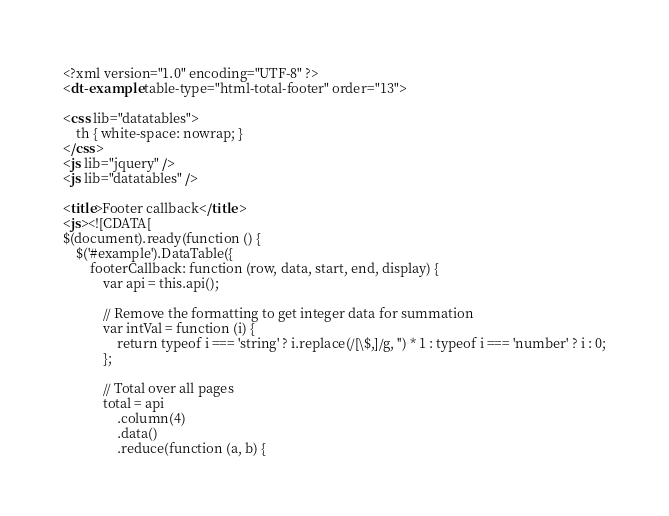Convert code to text. <code><loc_0><loc_0><loc_500><loc_500><_XML_><?xml version="1.0" encoding="UTF-8" ?>
<dt-example table-type="html-total-footer" order="13">

<css lib="datatables">
	th { white-space: nowrap; }
</css>
<js lib="jquery" />
<js lib="datatables" />

<title>Footer callback</title>
<js><![CDATA[
$(document).ready(function () {
	$('#example').DataTable({
		footerCallback: function (row, data, start, end, display) {
			var api = this.api();

			// Remove the formatting to get integer data for summation
			var intVal = function (i) {
				return typeof i === 'string' ? i.replace(/[\$,]/g, '') * 1 : typeof i === 'number' ? i : 0;
			};

			// Total over all pages
			total = api
				.column(4)
				.data()
				.reduce(function (a, b) {</code> 